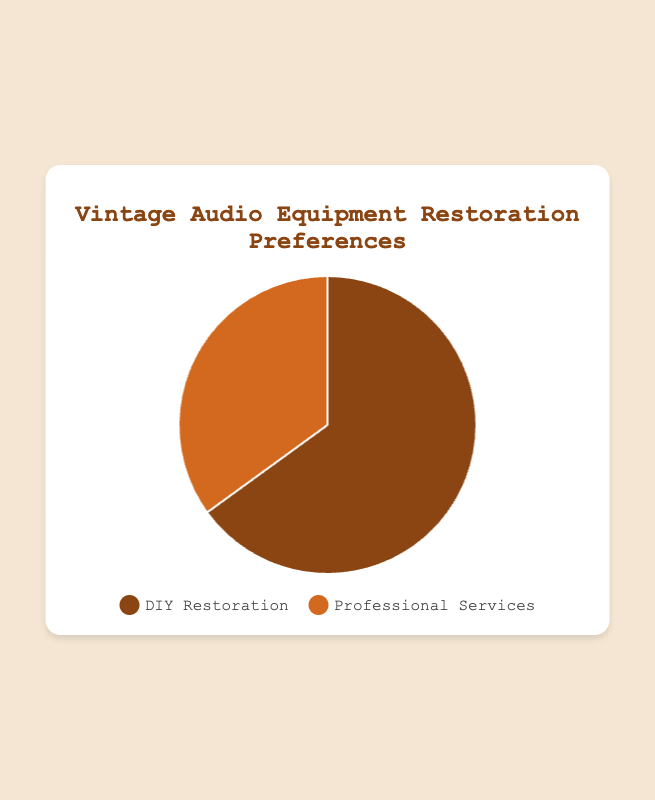Which restoration preference has a higher percentage of readers, DIY Restoration or Professional Services? DIY Restoration has 65% while Professional Services has 35%. Comparing these, DIY Restoration has a higher percentage.
Answer: DIY Restoration How many percentage points more readers prefer DIY Restoration over Professional Services? DIY Restoration has 65% and Professional Services has 35%. The difference in preference is calculated as 65% - 35% = 30%.
Answer: 30% What is the total percentage represented by both DIY Restoration and Professional Services? The percentage for both categories should sum up to the whole chart because they represent all reader preferences. Therefore, 65% + 35% = 100%.
Answer: 100% What is the ratio of readers who prefer DIY Restoration to those who prefer Professional Services? The percentage of readers who prefer DIY Restoration is 65% while 35% prefer Professional Services. Hence, the ratio is 65:35. Simplifying this by dividing both numbers by their greatest common divisor, 5, we get 13:7.
Answer: 13:7 If the number of responses totaled 200, how many readers preferred Professional Services? Given the total responses are 200 and 35% of readers prefer Professional Services, the number can be calculated using: (35/100) * 200 = 70.
Answer: 70 What color represents the readers who prefer DIY Restoration in the pie chart? In the pie chart, the color used to represent DIY Restoration is brown.
Answer: brown Is the segment representing Professional Services in the pie chart larger or smaller than the segment for DIY Restoration? The segment representing Professional Services is smaller than the segment for DIY Restoration. The segment for DIY Restoration is visibly larger.
Answer: smaller If 300 readers participated in the survey, how many more readers prefer DIY Restoration than Professional Services? First, calculate the number of readers for each category: DIY Restoration: (65/100) * 300 = 195, Professional Services: (35/100) * 300 = 105. The difference is 195 - 105 = 90.
Answer: 90 